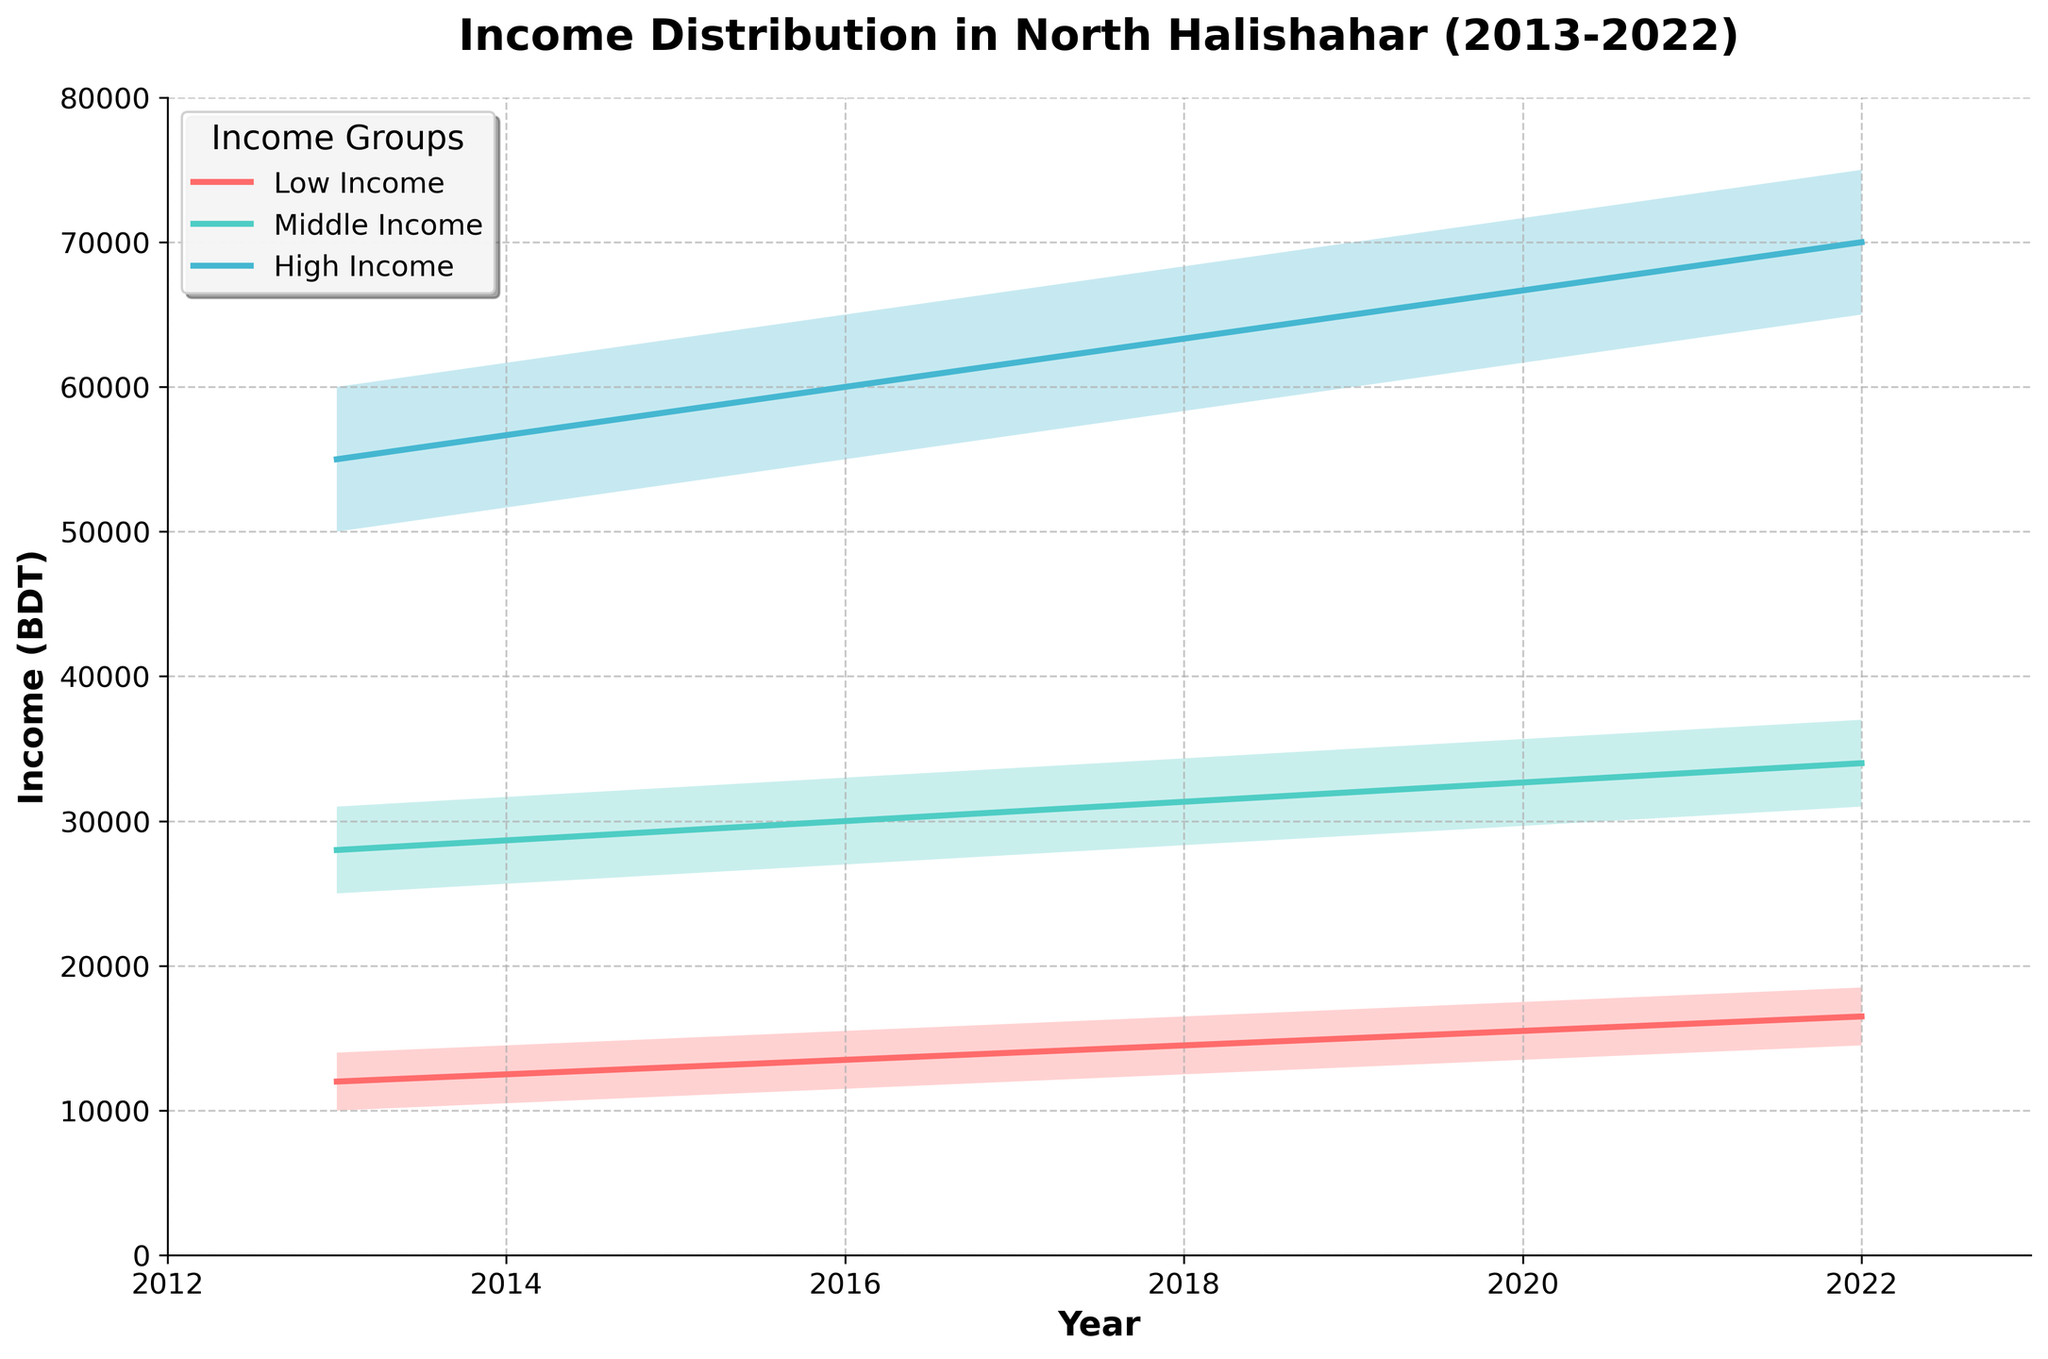What's the title of the chart? The title is generally located at the top of the chart. It provides an overview of the chart's content. Here, it reads 'Income Distribution in North Halishahar (2013-2022)'.
Answer: Income Distribution in North Halishahar (2013-2022) What are the years shown on the x-axis? The x-axis represents time, so it lists the years that are included. Here, the years 2013, 2016, 2019, and 2022 are shown.
Answer: 2013, 2016, 2019, 2022 Which income group had the highest mid estimate in 2022? Look at the lines representing the mid estimates for the three income groups for the year 2022. The 'High Income' group has the highest value at 70,000 BDT.
Answer: High Income How has the mid estimate for the Low Income group changed from 2013 to 2022? Locate the 'Low Income' group's mid estimates for 2013 (12,000 BDT) and 2022 (16,500 BDT), and calculate the difference. The increase is 16,500 - 12,000 = 4,500 BDT.
Answer: Increased by 4,500 BDT Which year showed the greatest difference between the High Income and Middle Income groups' mid estimates? Calculate the differences in mid estimates between the High and Middle Income groups for each year using the plotted values: 
2013: 55,000 - 28,000 = 27,000 BDT
2016: 60,000 - 30,000 = 30,000 BDT
2019: 65,000 - 32,000 = 33,000 BDT
2022: 70,000 - 34,000 = 36,000 BDT
The greatest difference is in 2022 with 36,000 BDT.
Answer: 2022 What is the range of income for the Middle Income group in 2019? The range of income is calculated by subtracting the low estimate from the high estimate for the Middle Income group in 2019. The values are 35,000 - 29,000 = 6,000 BDT.
Answer: 6,000 BDT Which income group has the widest range in any given year? Compare the income ranges (high estimate - low estimate) for each group across all years.
Low Income: 4,000; 4,000; 4,000; 4,000
Middle Income: 6,000; 6,000; 6,000; 6,000
High Income: 10,000; 10,000; 10,000; 10,000
The High Income group consistently has the widest range at 10,000 BDT.
Answer: High Income How much did the low estimate for the Middle Income group increase from 2013 to 2022? Locate the low estimate values for the Middle Income group in 2013 (25,000 BDT) and in 2022 (31,000 BDT), then calculate the difference: 31,000 - 25,000 = 6,000 BDT.
Answer: Increased by 6,000 BDT Which income group's mid estimate showed the least change between 2013 and 2016? Examine the changes in mid estimates from 2013 to 2016:
Low Income: 13,500 - 12,000 = 1,500 BDT
Middle Income: 30,000 - 28,000 = 2,000 BDT
High Income: 60,000 - 55,000 = 5,000 BDT
The Low Income group showed the least change, increasing by 1,500 BDT.
Answer: Low Income What’s the average mid estimate for the High Income group across the four years shown? Calculate the average of the mid estimates for the High Income group in 2013, 2016, 2019, and 2022:
(55,000 + 60,000 + 65,000 + 70,000) / 4 = 62,500 BDT.
Answer: 62,500 BDT 